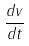Convert formula to latex. <formula><loc_0><loc_0><loc_500><loc_500>\frac { d v } { d t }</formula> 